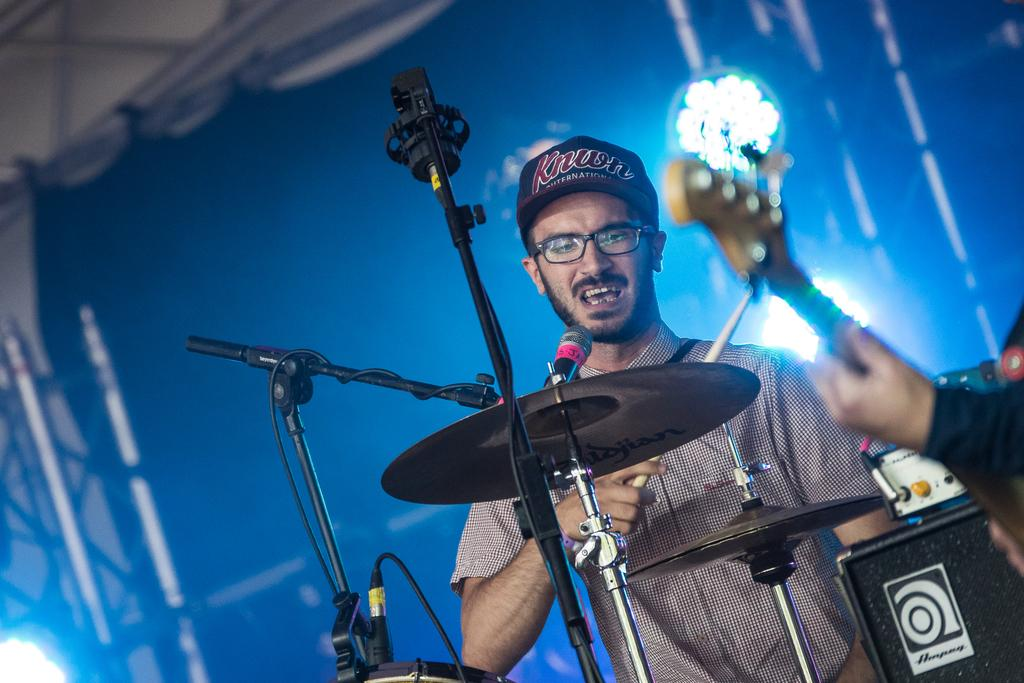How many people are in the image? There are two persons in the image. Where are the persons located in relation to the image? The persons are in front. What else can be seen in the image besides the people? There are musical instruments in the image. What can be seen in the background of the image? There are lights in the background of the image. What objects are present in front of the image? There are tripods in front of the image. Can you see a kitty playing with a feather on top of the musical instruments in the image? There is no kitty or feather present on top of the musical instruments in the image. 